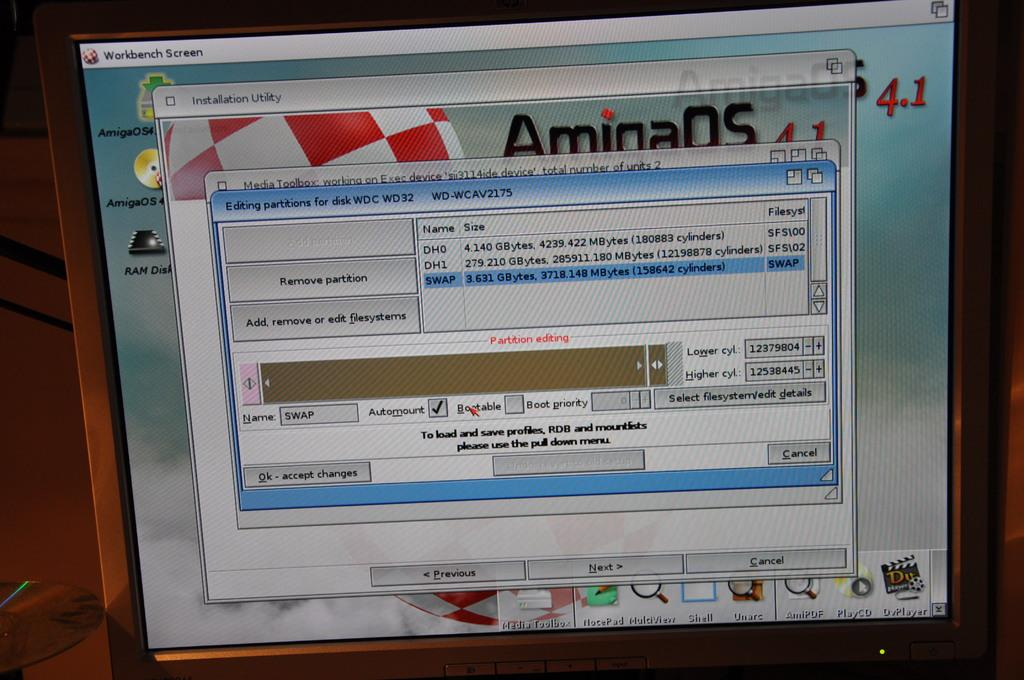Provide a one-sentence caption for the provided image. A partitioning program is opened on a computer display. 